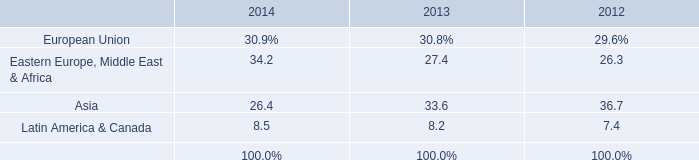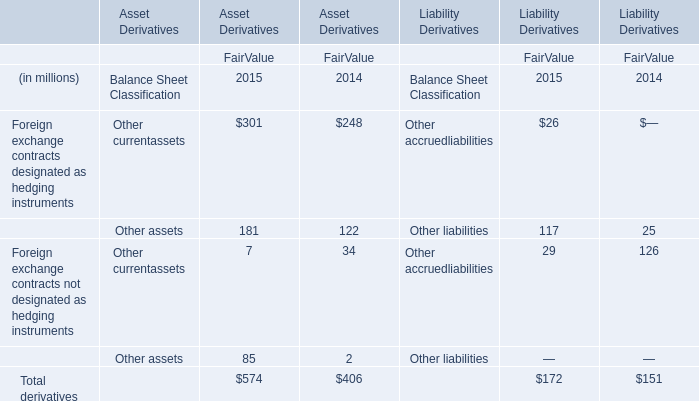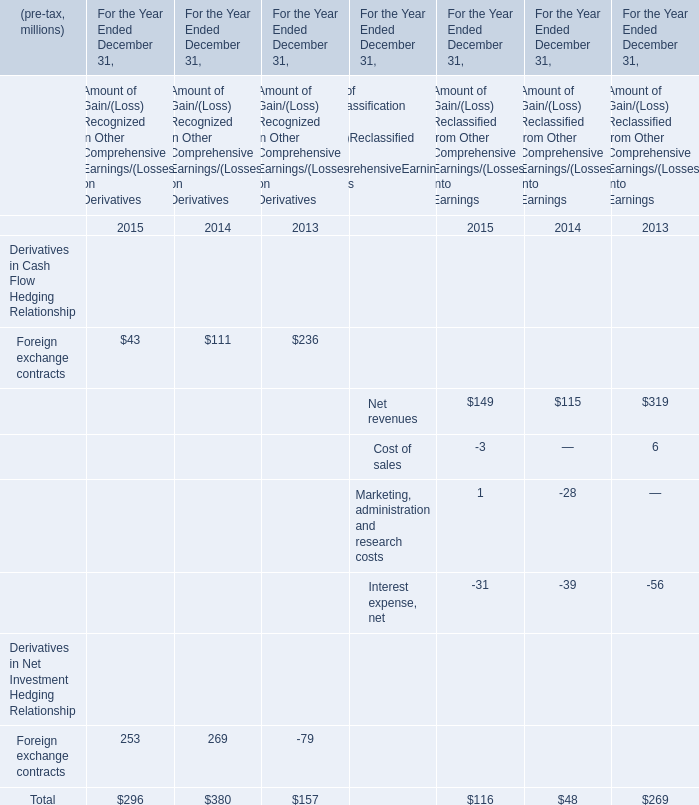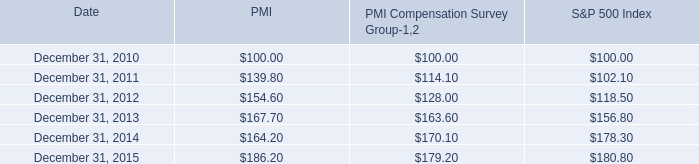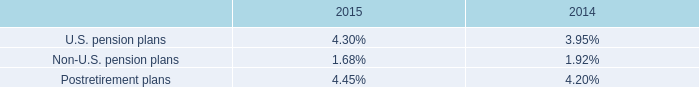what was the change in millions of trade receivables sold from 2014 to 2015? 
Computations: (888 - 120)
Answer: 768.0. 